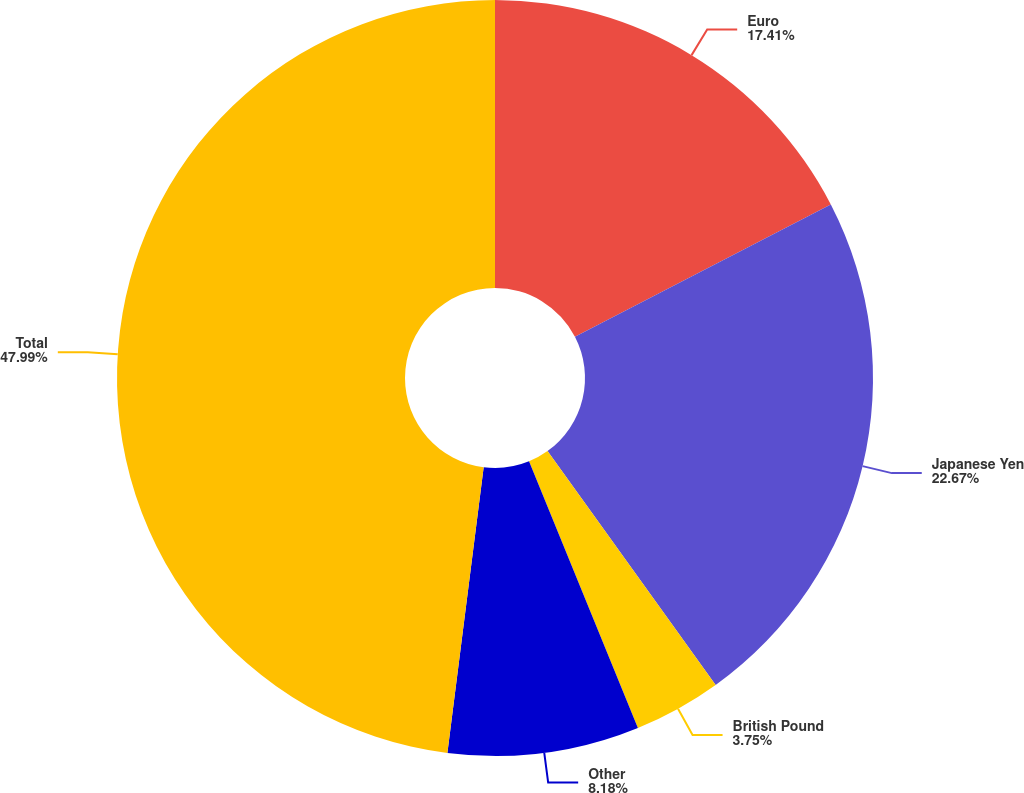Convert chart. <chart><loc_0><loc_0><loc_500><loc_500><pie_chart><fcel>Euro<fcel>Japanese Yen<fcel>British Pound<fcel>Other<fcel>Total<nl><fcel>17.41%<fcel>22.67%<fcel>3.75%<fcel>8.18%<fcel>47.99%<nl></chart> 